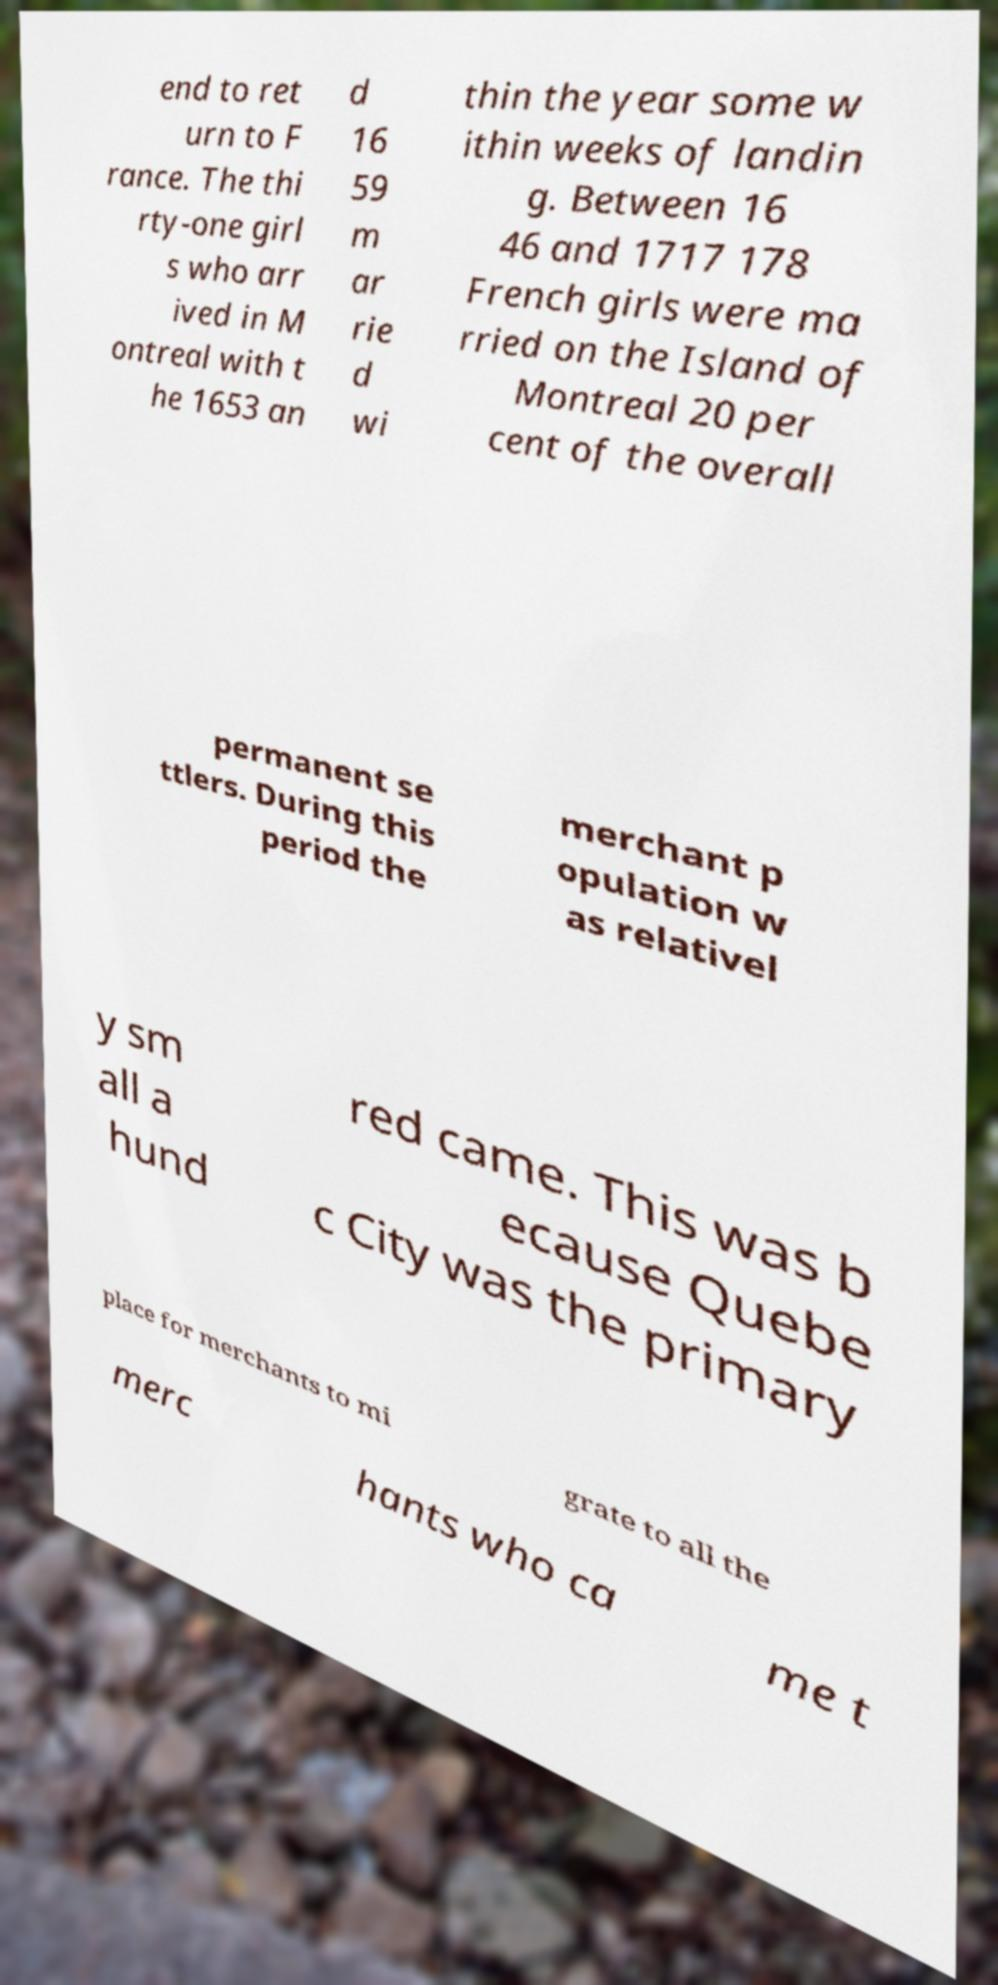Could you extract and type out the text from this image? end to ret urn to F rance. The thi rty-one girl s who arr ived in M ontreal with t he 1653 an d 16 59 m ar rie d wi thin the year some w ithin weeks of landin g. Between 16 46 and 1717 178 French girls were ma rried on the Island of Montreal 20 per cent of the overall permanent se ttlers. During this period the merchant p opulation w as relativel y sm all a hund red came. This was b ecause Quebe c City was the primary place for merchants to mi grate to all the merc hants who ca me t 